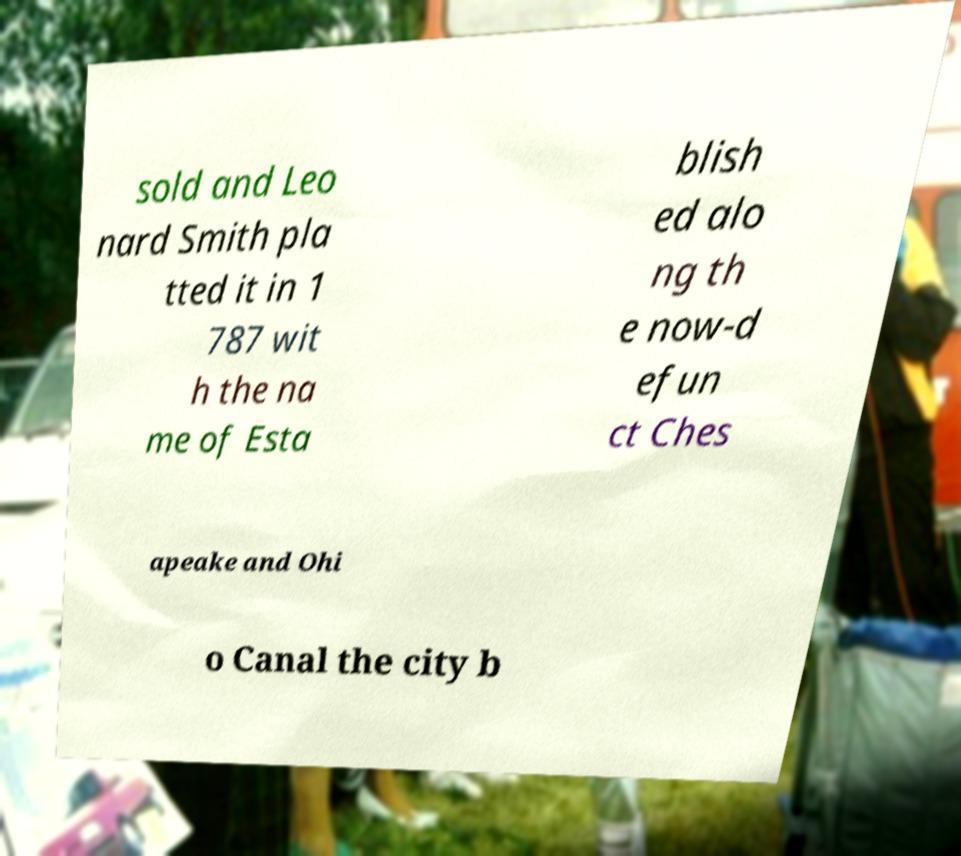Could you assist in decoding the text presented in this image and type it out clearly? sold and Leo nard Smith pla tted it in 1 787 wit h the na me of Esta blish ed alo ng th e now-d efun ct Ches apeake and Ohi o Canal the city b 